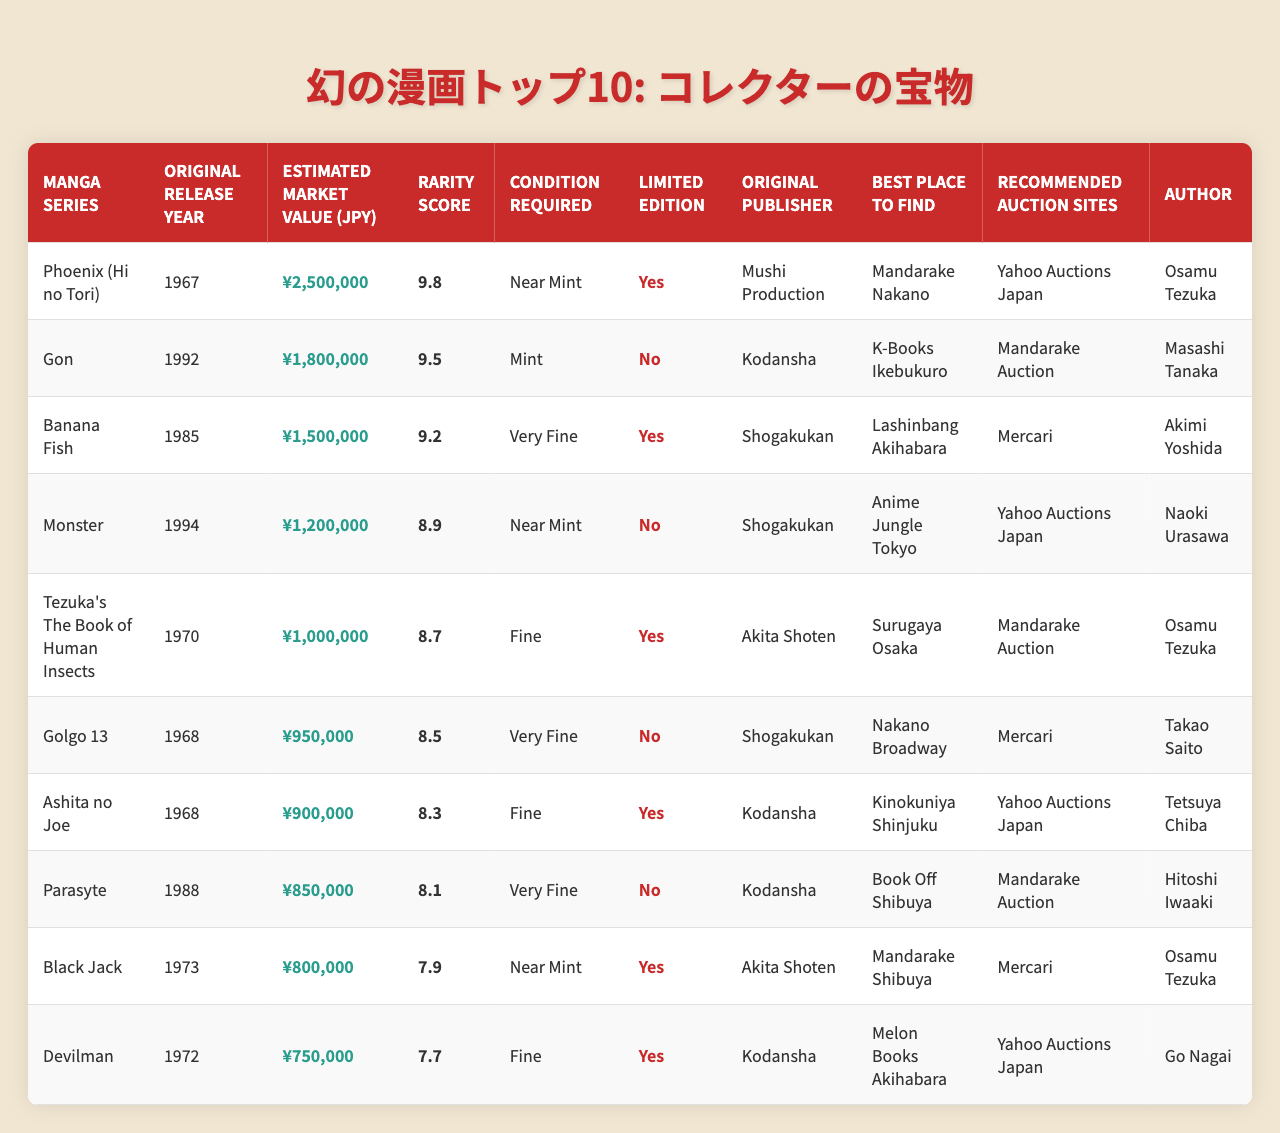What is the estimated market value of "Phoenix"? According to the table, the estimated market value of "Phoenix (Hi no Tori)" is listed as ¥2,500,000.
Answer: ¥2,500,000 Which manga series has the highest rarity score? The table indicates that "Phoenix (Hi no Tori)" has a rarity score of 9.8, which is higher than the other series.
Answer: Phoenix (Hi no Tori) Are there any manga series that were published by Akita Shoten? Yes, the table shows that "Tezuka's The Book of Human Insects," "Black Jack," and "Devilman" were published by Akita Shoten.
Answer: Yes What is the average estimated market value of the listed manga series? To calculate the average, first sum all the values: ¥2,500,000 + ¥1,800,000 + ¥1,500,000 + ¥1,200,000 + ¥1,000,000 + ¥950,000 + ¥900,000 + ¥850,000 + ¥800,000 + ¥750,000 = ¥12,200,000. Then divide by the number of series (10): ¥12,200,000 / 10 = ¥1,220,000.
Answer: ¥1,220,000 How many series have a "Mint" or "Near Mint" condition requirement? From the table, "Mint" is for "Gon," and "Near Mint" is for "Phoenix," "Monster," "Ashita no Joe," and "Parasyte." In total, there are 5 series requiring either "Mint" or "Near Mint."
Answer: 5 Which limited edition manga series is authored by Osamu Tezuka? The series "Phoenix (Hi no Tori)," "Tezuka's The Book of Human Insects," and "Black Jack" are all limited editions authored by Osamu Tezuka, but only "Phoenix" is listed as a limited edition in the table.
Answer: Phoenix (Hi no Tori) Find the difference between the highest and lowest market values in the table. The highest market value is ¥2,500,000 (for "Phoenix"), and the lowest is ¥750,000 (for "Devilman"). The difference is ¥2,500,000 - ¥750,000 = ¥1,750,000.
Answer: ¥1,750,000 Which series is the best option to find at Mandarake Nakano? According to the table, "Phoenix (Hi no Tori)" is the best series to find at Mandarake Nakano.
Answer: Phoenix (Hi no Tori) How many manga series have a rarity score above 9.0? Looking at the rarity scores, "Phoenix (Hi no Tori)," "Gon," "Banana Fish," "Monster," and "Tezuka's The Book of Human Insects" all have scores above 9.0. This gives a total of 5 series.
Answer: 5 Is "Golgo 13" a limited edition? The table clearly states that "Golgo 13" is not a limited edition.
Answer: No 